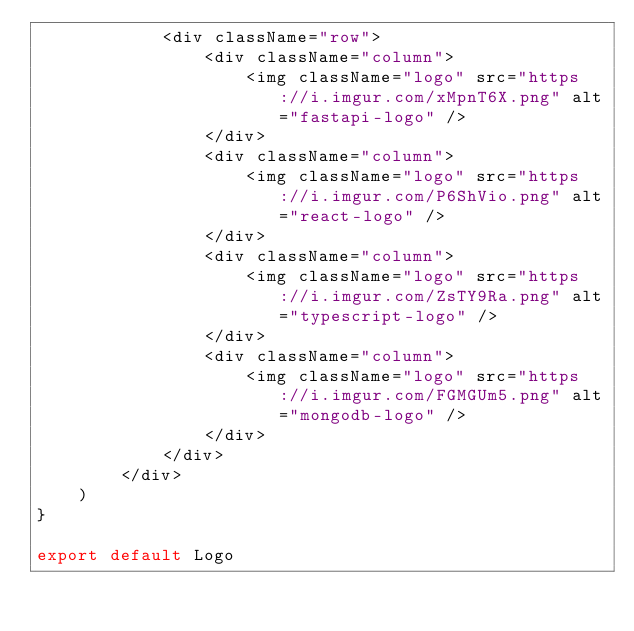Convert code to text. <code><loc_0><loc_0><loc_500><loc_500><_TypeScript_>            <div className="row">
                <div className="column">
                    <img className="logo" src="https://i.imgur.com/xMpnT6X.png" alt="fastapi-logo" />
                </div>
                <div className="column">
                    <img className="logo" src="https://i.imgur.com/P6ShVio.png" alt="react-logo" />
                </div>
                <div className="column">
                    <img className="logo" src="https://i.imgur.com/ZsTY9Ra.png" alt="typescript-logo" />
                </div>
                <div className="column">
                    <img className="logo" src="https://i.imgur.com/FGMGUm5.png" alt="mongodb-logo" />
                </div>
            </div>
        </div>
    )
}

export default Logo
</code> 